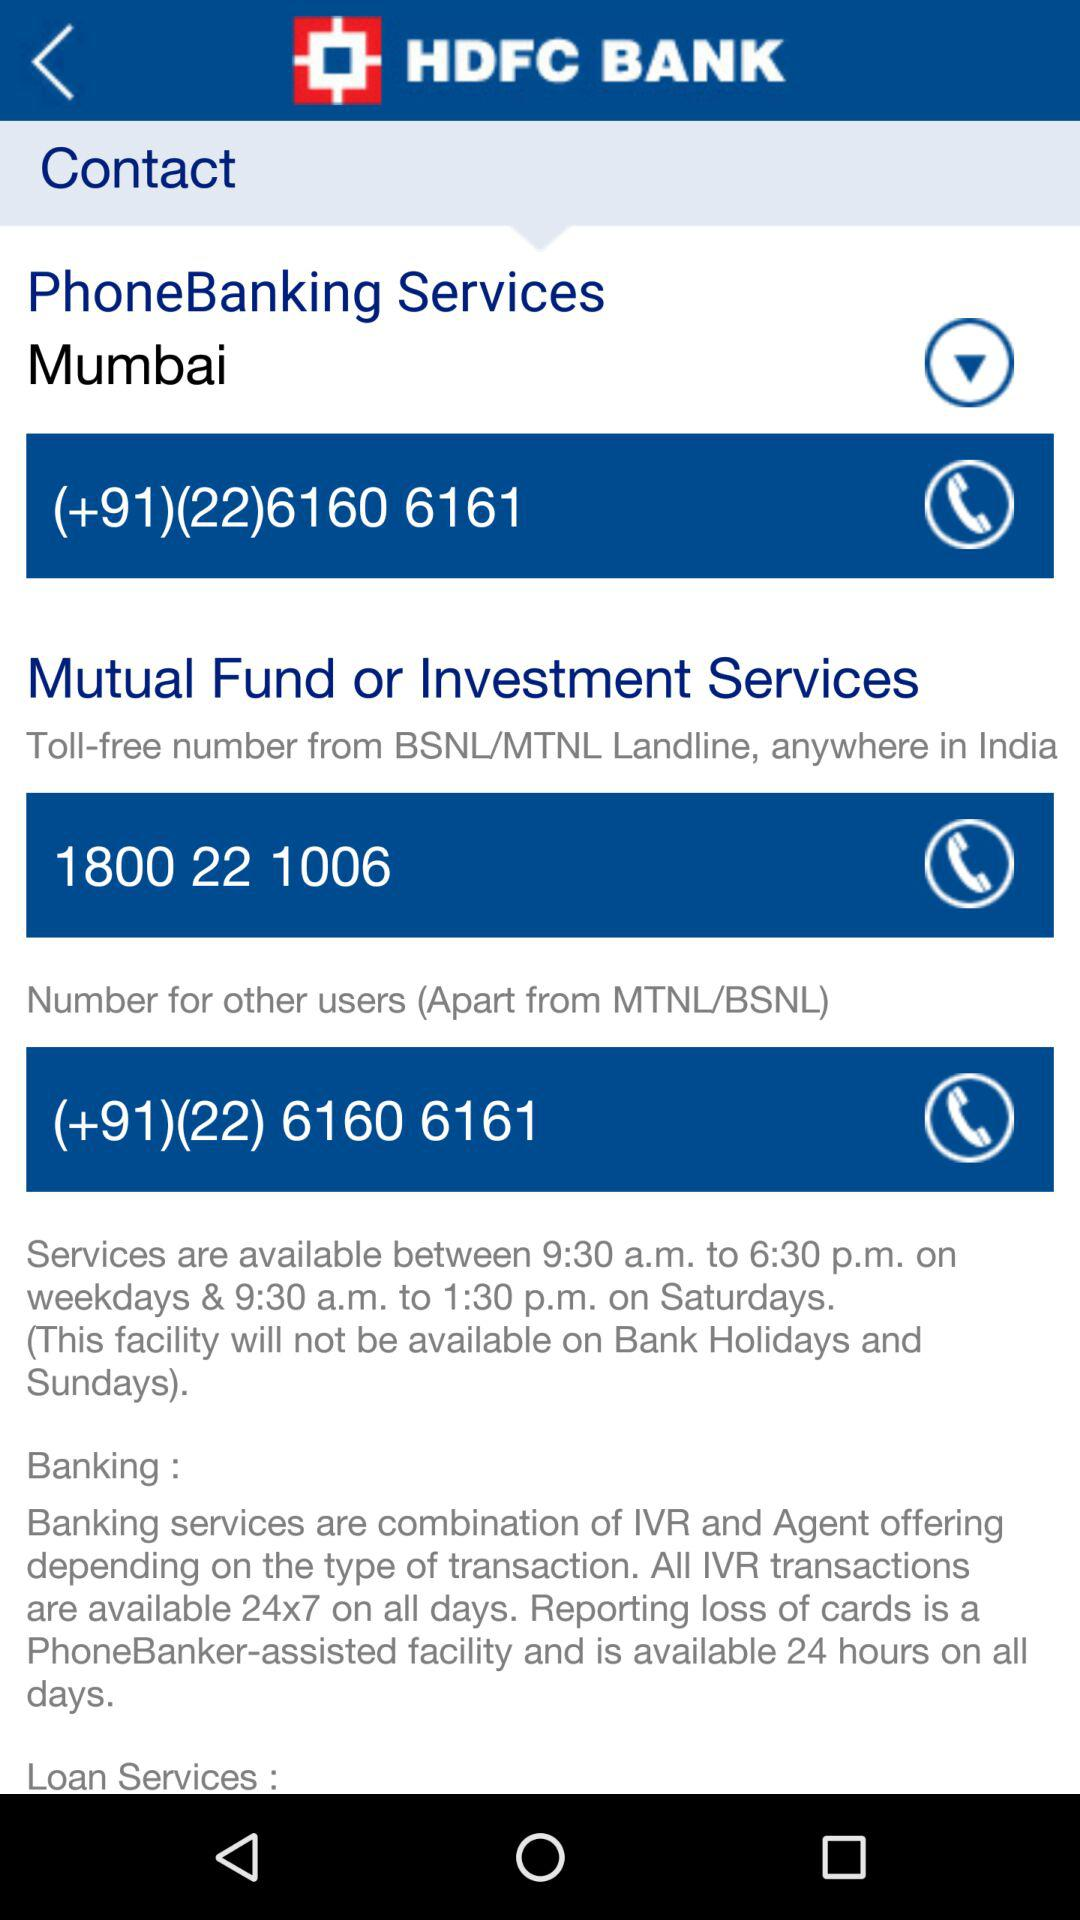What is the contact number for phone banking services? The contact number for phone banking services is +912261606161. 